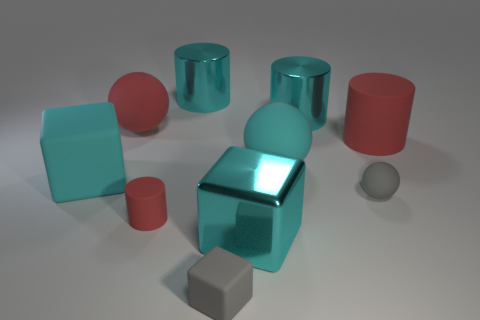Subtract 1 balls. How many balls are left? 2 Subtract all tiny rubber cylinders. How many cylinders are left? 3 Subtract all blue cylinders. Subtract all gray cubes. How many cylinders are left? 4 Subtract all cubes. How many objects are left? 7 Add 2 small gray matte objects. How many small gray matte objects are left? 4 Add 7 cyan cubes. How many cyan cubes exist? 9 Subtract 0 brown balls. How many objects are left? 10 Subtract all tiny matte things. Subtract all cyan cubes. How many objects are left? 5 